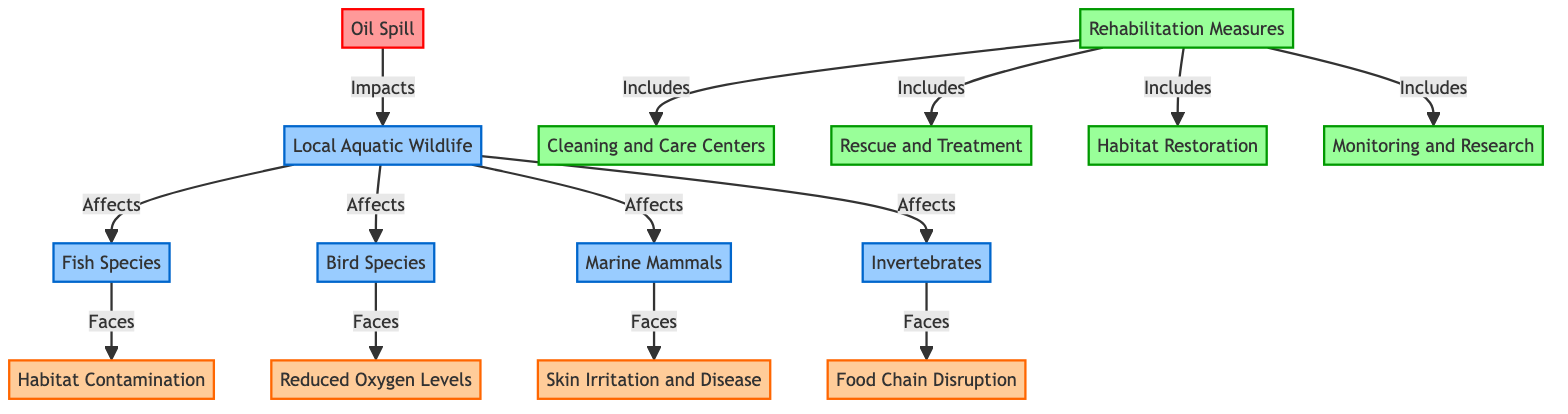What is the main cause of impact in the diagram? The main cause of impact in the diagram is the "Oil Spill" at the top. It affects local aquatic wildlife, creating a cascade effect on various species and environmental factors.
Answer: Oil Spill How many species types are affected by the oil spill? Four types of species are affected by the oil spill: Fish Species, Bird Species, Marine Mammals, and Invertebrates. This is identified by counting the direct connections to the "Local Aquatic Wildlife" node.
Answer: Four What is one effect faced by Fish Species? Fish Species face "Habitat Contamination." This is indicated by the direct connection from "Fish Species" to "Habitat Contamination" in the diagram.
Answer: Habitat Contamination Which species faces skin irritation and disease? Marine Mammals face "Skin Irritation and Disease." This information can be found by tracing the connection from "Marine Mammals" to that specific effect in the diagram.
Answer: Marine Mammals Name one rehabilitation measure included in the diagram. One rehabilitation measure included is "Habitat Restoration." This is found under the "Rehabilitation Measures" section, where it lists various actions to address the impacts of the oil spill.
Answer: Habitat Restoration What are the two main categorized effects associated with the oil spill in wildlife? The two main categorized effects are "Habitat Contamination" and "Reduced Oxygen Levels." Both are shown in the diagram as specific impacts that local aquatic wildlife faces, linked to different species.
Answer: Habitat Contamination and Reduced Oxygen Levels How does the oil spill impact local aquatic wildlife? The oil spill impacts local aquatic wildlife through various effects like habitat contamination, reduced oxygen levels, and food chain disruption. These connections illustrate the systematic consequences of the spill on different wildlife species.
Answer: Through habitat contamination, reduced oxygen levels, and food chain disruption What includes the rehabilitation measures? The rehabilitation measures include "Cleaning and Care Centers," "Rescue and Treatment," "Habitat Restoration," and "Monitoring and Research." This is captured under the "Rehabilitation Measures" node, detailing the steps taken to mitigate the oil spill's effects.
Answer: Cleaning and Care Centers, Rescue and Treatment, Habitat Restoration, Monitoring and Research 